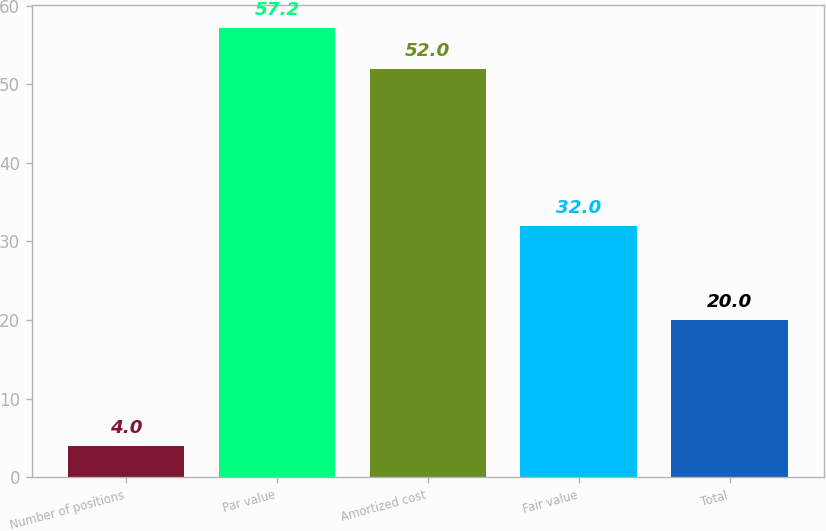Convert chart. <chart><loc_0><loc_0><loc_500><loc_500><bar_chart><fcel>Number of positions<fcel>Par value<fcel>Amortized cost<fcel>Fair value<fcel>Total<nl><fcel>4<fcel>57.2<fcel>52<fcel>32<fcel>20<nl></chart> 